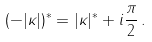<formula> <loc_0><loc_0><loc_500><loc_500>( - | \kappa | ) ^ { * } = | \kappa | ^ { * } + i \frac { \pi } { 2 } \, .</formula> 